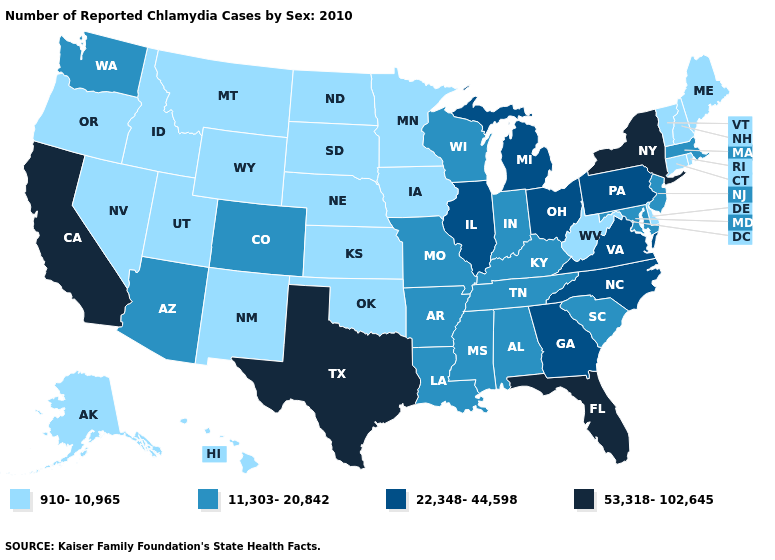What is the value of Texas?
Keep it brief. 53,318-102,645. Name the states that have a value in the range 910-10,965?
Be succinct. Alaska, Connecticut, Delaware, Hawaii, Idaho, Iowa, Kansas, Maine, Minnesota, Montana, Nebraska, Nevada, New Hampshire, New Mexico, North Dakota, Oklahoma, Oregon, Rhode Island, South Dakota, Utah, Vermont, West Virginia, Wyoming. Does Wisconsin have the highest value in the MidWest?
Short answer required. No. Does Colorado have the lowest value in the West?
Give a very brief answer. No. What is the highest value in states that border Virginia?
Be succinct. 22,348-44,598. What is the lowest value in states that border North Carolina?
Short answer required. 11,303-20,842. Name the states that have a value in the range 53,318-102,645?
Concise answer only. California, Florida, New York, Texas. Name the states that have a value in the range 22,348-44,598?
Give a very brief answer. Georgia, Illinois, Michigan, North Carolina, Ohio, Pennsylvania, Virginia. Does Washington have a higher value than Illinois?
Be succinct. No. Among the states that border Massachusetts , does Connecticut have the highest value?
Write a very short answer. No. Does Arkansas have the same value as Vermont?
Concise answer only. No. Among the states that border Alabama , which have the highest value?
Quick response, please. Florida. Which states have the lowest value in the USA?
Quick response, please. Alaska, Connecticut, Delaware, Hawaii, Idaho, Iowa, Kansas, Maine, Minnesota, Montana, Nebraska, Nevada, New Hampshire, New Mexico, North Dakota, Oklahoma, Oregon, Rhode Island, South Dakota, Utah, Vermont, West Virginia, Wyoming. What is the value of Virginia?
Concise answer only. 22,348-44,598. Among the states that border Pennsylvania , which have the lowest value?
Short answer required. Delaware, West Virginia. 